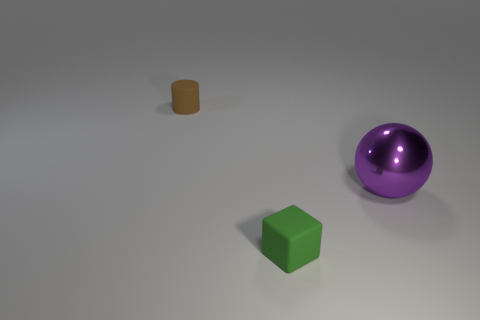Is there a tiny object that has the same material as the large purple object?
Provide a succinct answer. No. Are there fewer small brown rubber cylinders that are in front of the tiny green object than large brown metal objects?
Your response must be concise. No. There is a rubber thing that is behind the green rubber cube; is its size the same as the purple metal object?
Ensure brevity in your answer.  No. What size is the brown cylinder that is the same material as the green block?
Your answer should be very brief. Small. Are there the same number of tiny matte cubes behind the small green block and large purple metal spheres?
Provide a short and direct response. No. Is the metal thing the same color as the small cylinder?
Offer a terse response. No. Is the shape of the rubber object in front of the metal object the same as the matte thing that is behind the metal object?
Give a very brief answer. No. The object that is both right of the brown thing and on the left side of the metal sphere is what color?
Offer a very short reply. Green. Is there a purple shiny sphere that is behind the rubber thing on the left side of the matte thing in front of the brown object?
Provide a short and direct response. No. How many objects are yellow blocks or rubber things?
Make the answer very short. 2. 